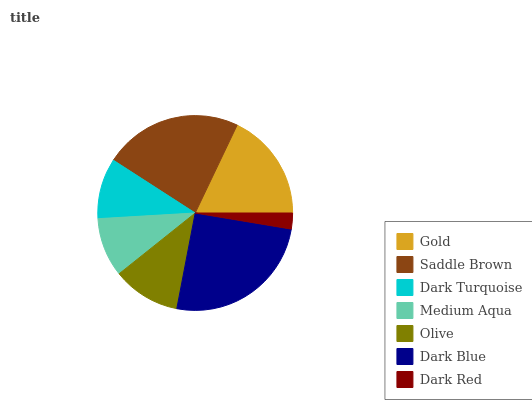Is Dark Red the minimum?
Answer yes or no. Yes. Is Dark Blue the maximum?
Answer yes or no. Yes. Is Saddle Brown the minimum?
Answer yes or no. No. Is Saddle Brown the maximum?
Answer yes or no. No. Is Saddle Brown greater than Gold?
Answer yes or no. Yes. Is Gold less than Saddle Brown?
Answer yes or no. Yes. Is Gold greater than Saddle Brown?
Answer yes or no. No. Is Saddle Brown less than Gold?
Answer yes or no. No. Is Olive the high median?
Answer yes or no. Yes. Is Olive the low median?
Answer yes or no. Yes. Is Dark Turquoise the high median?
Answer yes or no. No. Is Saddle Brown the low median?
Answer yes or no. No. 